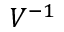Convert formula to latex. <formula><loc_0><loc_0><loc_500><loc_500>V ^ { - 1 }</formula> 